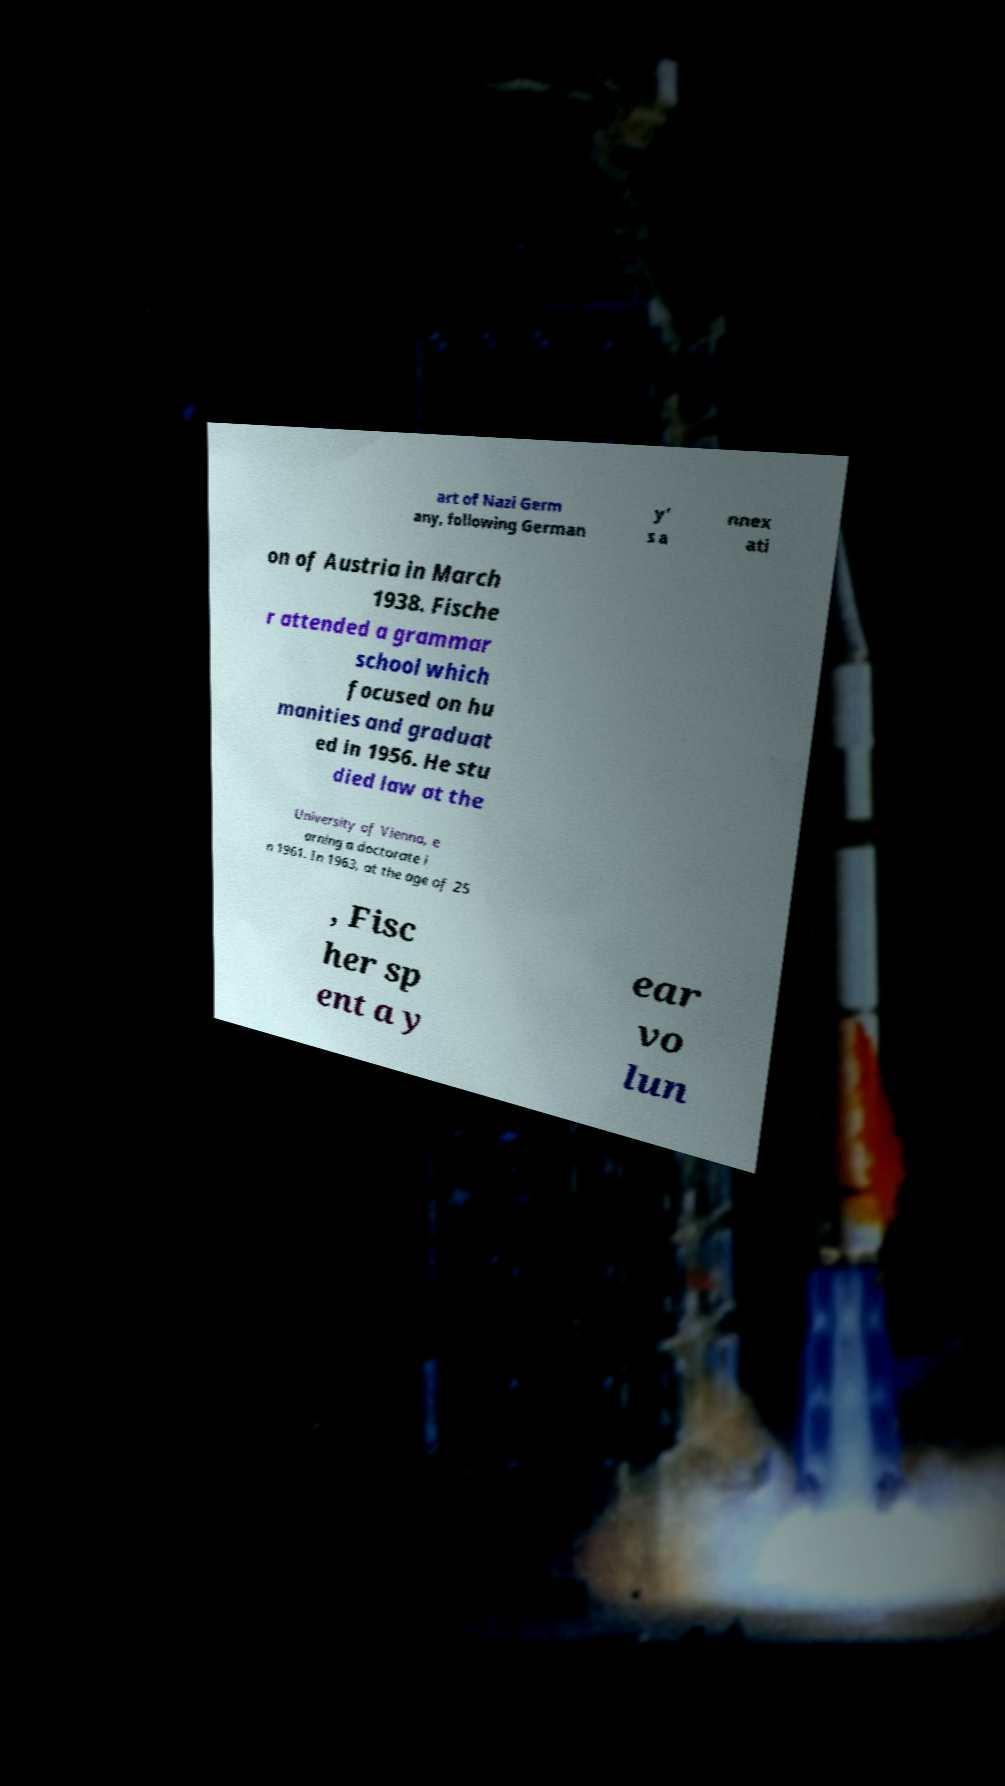Please read and relay the text visible in this image. What does it say? art of Nazi Germ any, following German y’ s a nnex ati on of Austria in March 1938. Fische r attended a grammar school which focused on hu manities and graduat ed in 1956. He stu died law at the University of Vienna, e arning a doctorate i n 1961. In 1963, at the age of 25 , Fisc her sp ent a y ear vo lun 